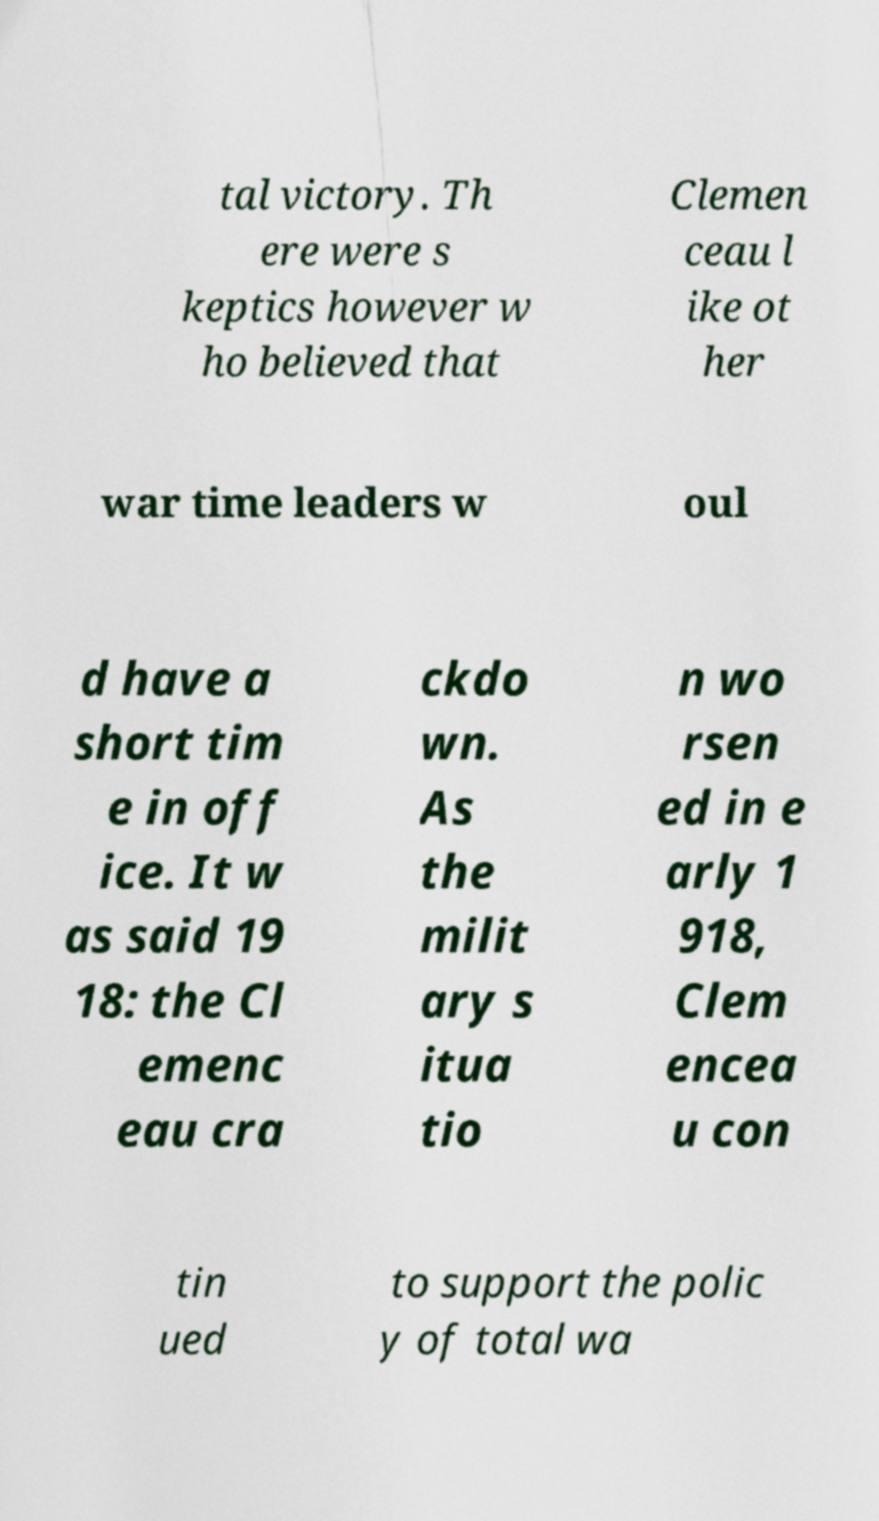Please identify and transcribe the text found in this image. tal victory. Th ere were s keptics however w ho believed that Clemen ceau l ike ot her war time leaders w oul d have a short tim e in off ice. It w as said 19 18: the Cl emenc eau cra ckdo wn. As the milit ary s itua tio n wo rsen ed in e arly 1 918, Clem encea u con tin ued to support the polic y of total wa 